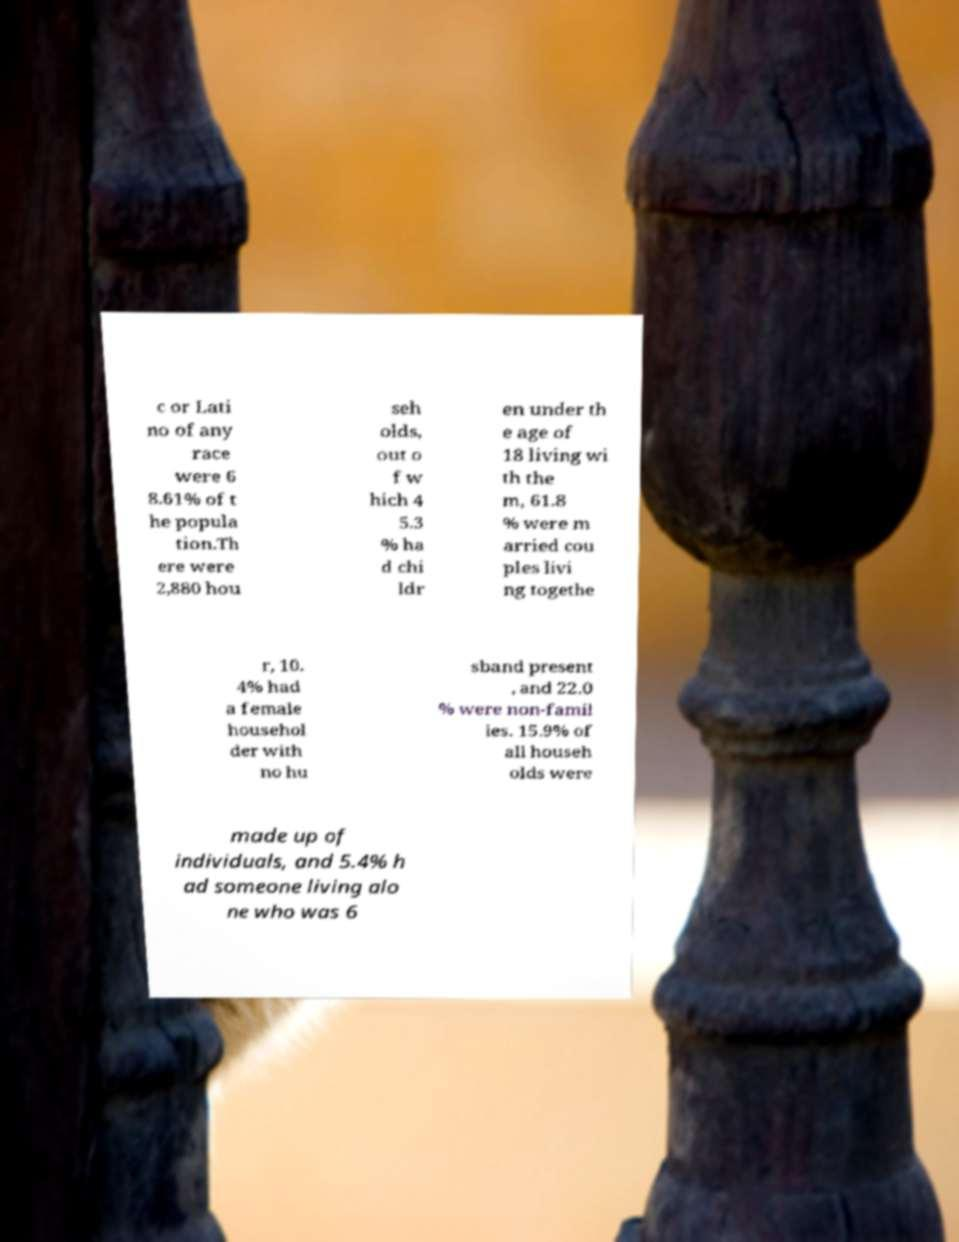Could you extract and type out the text from this image? c or Lati no of any race were 6 8.61% of t he popula tion.Th ere were 2,880 hou seh olds, out o f w hich 4 5.3 % ha d chi ldr en under th e age of 18 living wi th the m, 61.8 % were m arried cou ples livi ng togethe r, 10. 4% had a female househol der with no hu sband present , and 22.0 % were non-famil ies. 15.9% of all househ olds were made up of individuals, and 5.4% h ad someone living alo ne who was 6 